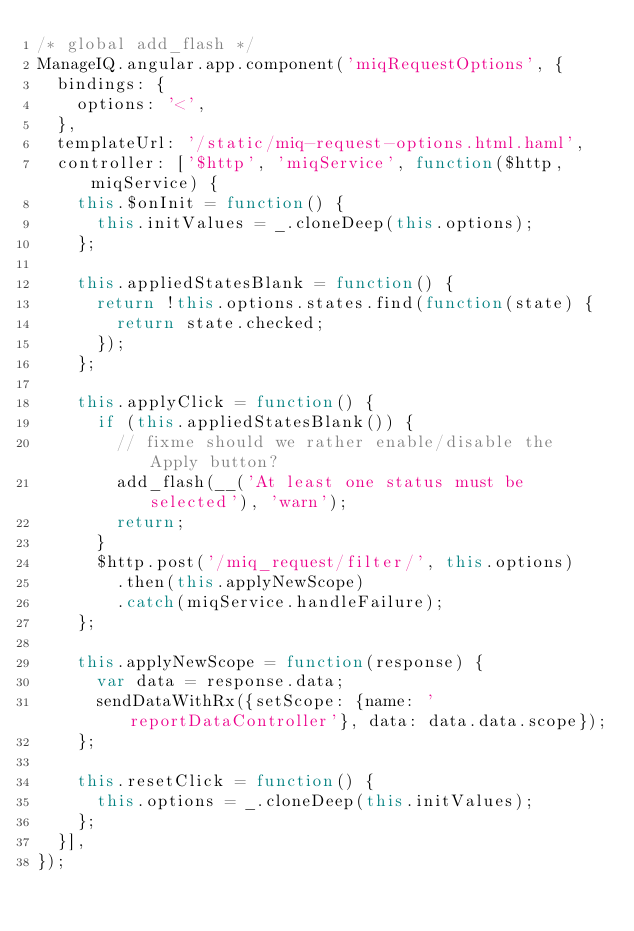Convert code to text. <code><loc_0><loc_0><loc_500><loc_500><_JavaScript_>/* global add_flash */
ManageIQ.angular.app.component('miqRequestOptions', {
  bindings: {
    options: '<',
  },
  templateUrl: '/static/miq-request-options.html.haml',
  controller: ['$http', 'miqService', function($http, miqService) {
    this.$onInit = function() {
      this.initValues = _.cloneDeep(this.options);
    };

    this.appliedStatesBlank = function() {
      return !this.options.states.find(function(state) {
        return state.checked;
      });
    };

    this.applyClick = function() {
      if (this.appliedStatesBlank()) {
        // fixme should we rather enable/disable the Apply button?
        add_flash(__('At least one status must be selected'), 'warn');
        return;
      }
      $http.post('/miq_request/filter/', this.options)
        .then(this.applyNewScope)
        .catch(miqService.handleFailure);
    };

    this.applyNewScope = function(response) {
      var data = response.data;
      sendDataWithRx({setScope: {name: 'reportDataController'}, data: data.data.scope});
    };

    this.resetClick = function() {
      this.options = _.cloneDeep(this.initValues);
    };
  }],
});
</code> 